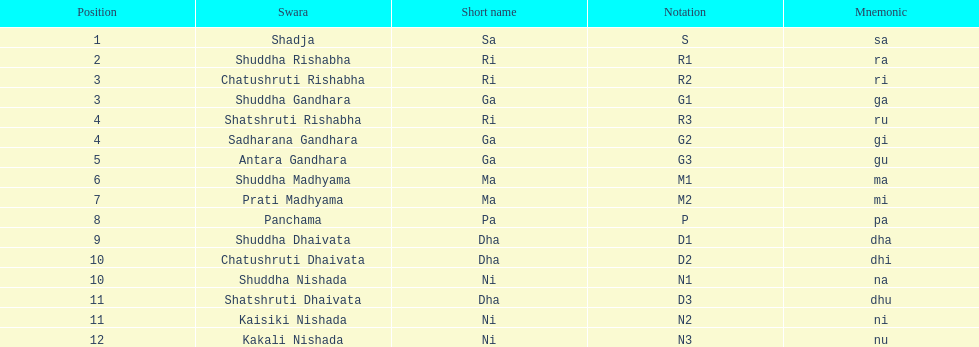On average, how many swara possess short names beginning with the letters d or g? 6. 